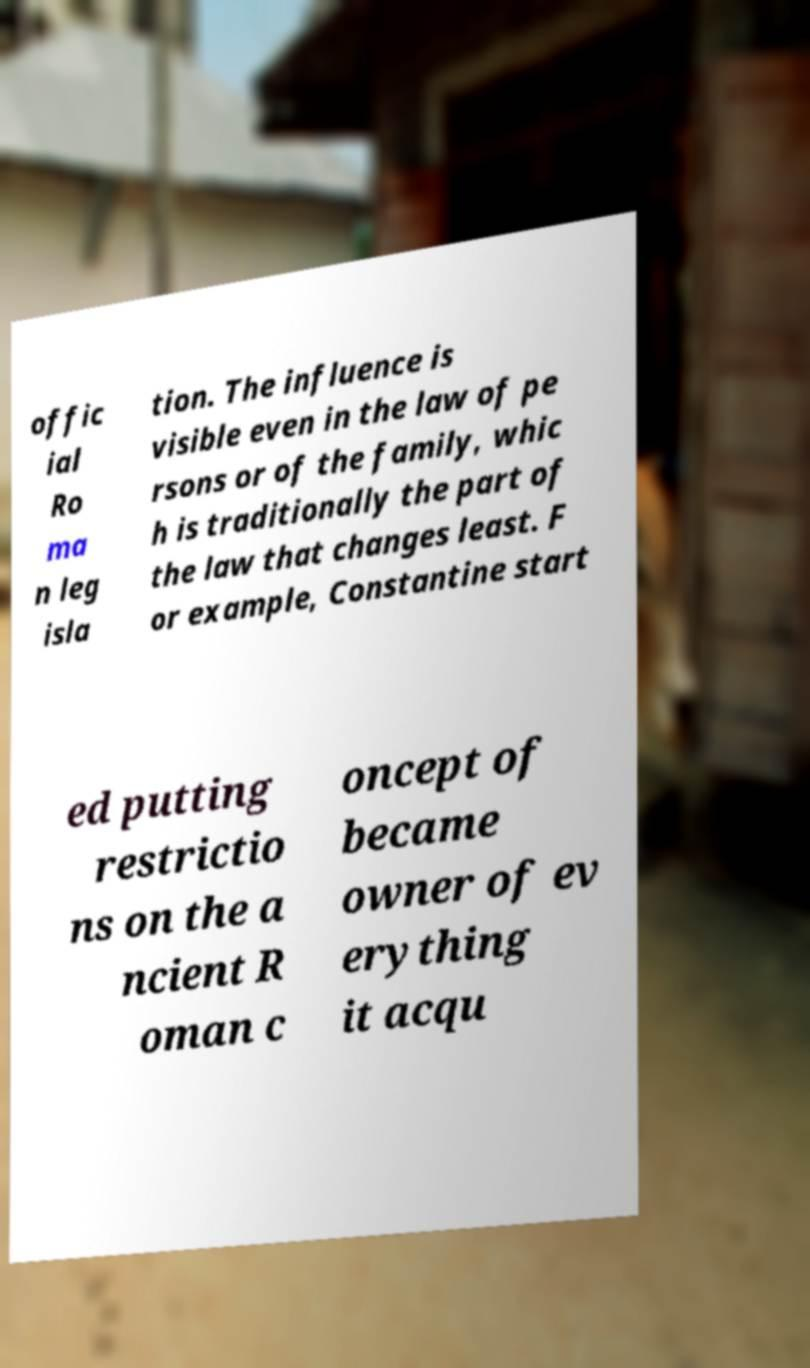Can you read and provide the text displayed in the image?This photo seems to have some interesting text. Can you extract and type it out for me? offic ial Ro ma n leg isla tion. The influence is visible even in the law of pe rsons or of the family, whic h is traditionally the part of the law that changes least. F or example, Constantine start ed putting restrictio ns on the a ncient R oman c oncept of became owner of ev erything it acqu 